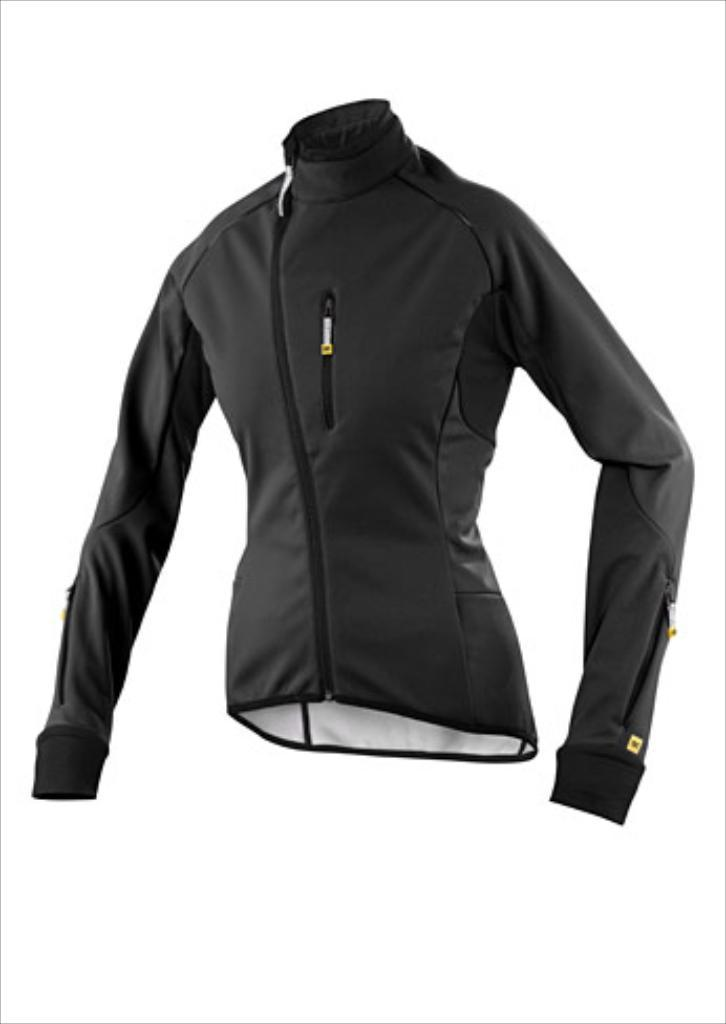What is the main subject in the foreground of the image? There is a black jacket in the foreground of the image. What is the color of the jacket? The jacket is black. What is the background color of the jacket? The background of the jacket is white. How many oranges are hanging from the jacket in the image? There are no oranges present in the image. What type of humor can be seen in the image? There is no humor depicted in the image; it is a simple image of a black jacket with a white background. 